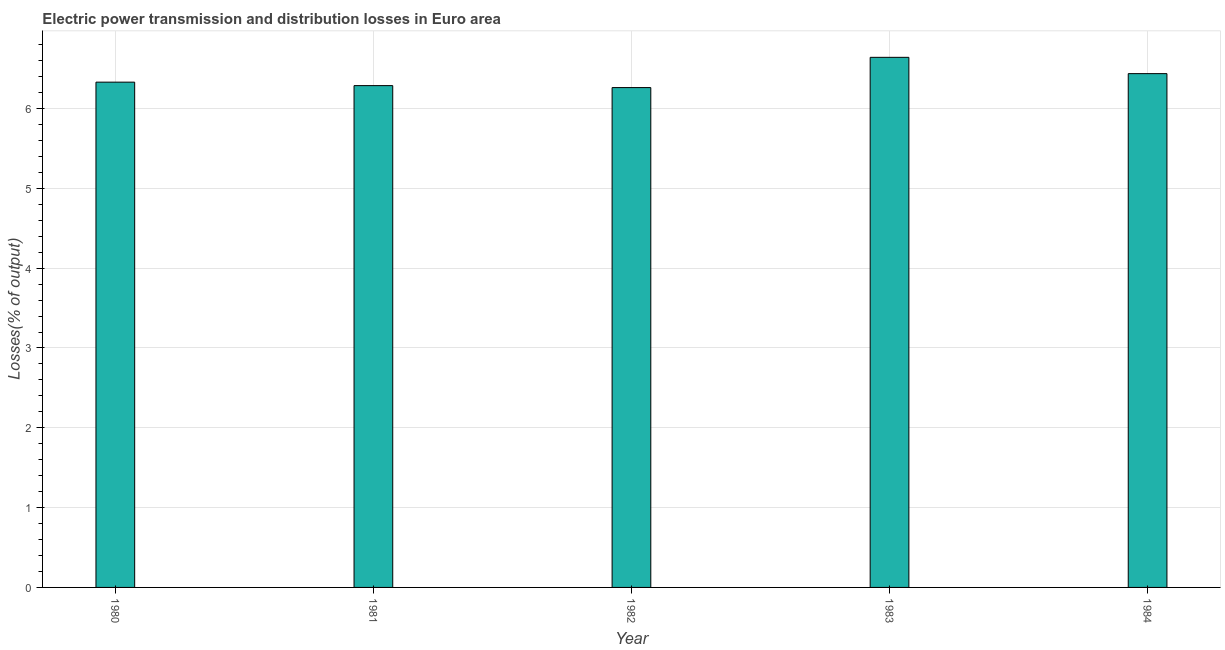Does the graph contain grids?
Give a very brief answer. Yes. What is the title of the graph?
Your answer should be compact. Electric power transmission and distribution losses in Euro area. What is the label or title of the Y-axis?
Ensure brevity in your answer.  Losses(% of output). What is the electric power transmission and distribution losses in 1984?
Offer a terse response. 6.44. Across all years, what is the maximum electric power transmission and distribution losses?
Your answer should be very brief. 6.64. Across all years, what is the minimum electric power transmission and distribution losses?
Keep it short and to the point. 6.26. In which year was the electric power transmission and distribution losses minimum?
Ensure brevity in your answer.  1982. What is the sum of the electric power transmission and distribution losses?
Ensure brevity in your answer.  31.96. What is the difference between the electric power transmission and distribution losses in 1982 and 1984?
Provide a succinct answer. -0.17. What is the average electric power transmission and distribution losses per year?
Make the answer very short. 6.39. What is the median electric power transmission and distribution losses?
Keep it short and to the point. 6.33. In how many years, is the electric power transmission and distribution losses greater than 1.6 %?
Provide a short and direct response. 5. Do a majority of the years between 1980 and 1981 (inclusive) have electric power transmission and distribution losses greater than 4.4 %?
Ensure brevity in your answer.  Yes. Is the difference between the electric power transmission and distribution losses in 1981 and 1984 greater than the difference between any two years?
Your answer should be very brief. No. What is the difference between the highest and the second highest electric power transmission and distribution losses?
Provide a succinct answer. 0.2. What is the difference between the highest and the lowest electric power transmission and distribution losses?
Keep it short and to the point. 0.38. Are all the bars in the graph horizontal?
Provide a succinct answer. No. How many years are there in the graph?
Ensure brevity in your answer.  5. What is the Losses(% of output) in 1980?
Your response must be concise. 6.33. What is the Losses(% of output) in 1981?
Your answer should be very brief. 6.29. What is the Losses(% of output) of 1982?
Offer a very short reply. 6.26. What is the Losses(% of output) in 1983?
Offer a very short reply. 6.64. What is the Losses(% of output) of 1984?
Provide a short and direct response. 6.44. What is the difference between the Losses(% of output) in 1980 and 1981?
Give a very brief answer. 0.04. What is the difference between the Losses(% of output) in 1980 and 1982?
Provide a short and direct response. 0.07. What is the difference between the Losses(% of output) in 1980 and 1983?
Give a very brief answer. -0.31. What is the difference between the Losses(% of output) in 1980 and 1984?
Offer a terse response. -0.11. What is the difference between the Losses(% of output) in 1981 and 1982?
Ensure brevity in your answer.  0.02. What is the difference between the Losses(% of output) in 1981 and 1983?
Your response must be concise. -0.35. What is the difference between the Losses(% of output) in 1981 and 1984?
Offer a very short reply. -0.15. What is the difference between the Losses(% of output) in 1982 and 1983?
Make the answer very short. -0.38. What is the difference between the Losses(% of output) in 1982 and 1984?
Provide a succinct answer. -0.17. What is the difference between the Losses(% of output) in 1983 and 1984?
Provide a short and direct response. 0.2. What is the ratio of the Losses(% of output) in 1980 to that in 1982?
Your answer should be very brief. 1.01. What is the ratio of the Losses(% of output) in 1980 to that in 1983?
Provide a succinct answer. 0.95. What is the ratio of the Losses(% of output) in 1981 to that in 1983?
Keep it short and to the point. 0.95. What is the ratio of the Losses(% of output) in 1981 to that in 1984?
Provide a short and direct response. 0.98. What is the ratio of the Losses(% of output) in 1982 to that in 1983?
Provide a succinct answer. 0.94. What is the ratio of the Losses(% of output) in 1983 to that in 1984?
Make the answer very short. 1.03. 